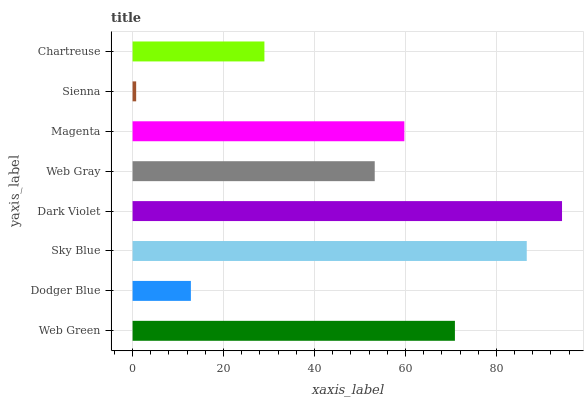Is Sienna the minimum?
Answer yes or no. Yes. Is Dark Violet the maximum?
Answer yes or no. Yes. Is Dodger Blue the minimum?
Answer yes or no. No. Is Dodger Blue the maximum?
Answer yes or no. No. Is Web Green greater than Dodger Blue?
Answer yes or no. Yes. Is Dodger Blue less than Web Green?
Answer yes or no. Yes. Is Dodger Blue greater than Web Green?
Answer yes or no. No. Is Web Green less than Dodger Blue?
Answer yes or no. No. Is Magenta the high median?
Answer yes or no. Yes. Is Web Gray the low median?
Answer yes or no. Yes. Is Web Gray the high median?
Answer yes or no. No. Is Dark Violet the low median?
Answer yes or no. No. 